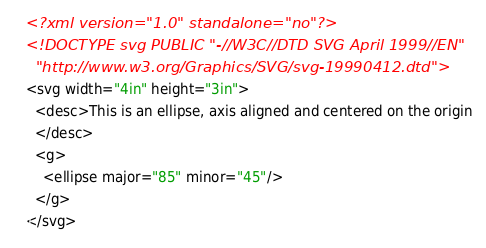<code> <loc_0><loc_0><loc_500><loc_500><_XML_><?xml version="1.0" standalone="no"?>
<!DOCTYPE svg PUBLIC "-//W3C//DTD SVG April 1999//EN" 
  "http://www.w3.org/Graphics/SVG/svg-19990412.dtd">
<svg width="4in" height="3in">
  <desc>This is an ellipse, axis aligned and centered on the origin
  </desc>
  <g>
    <ellipse major="85" minor="45"/>
  </g>
</svg>
</code> 